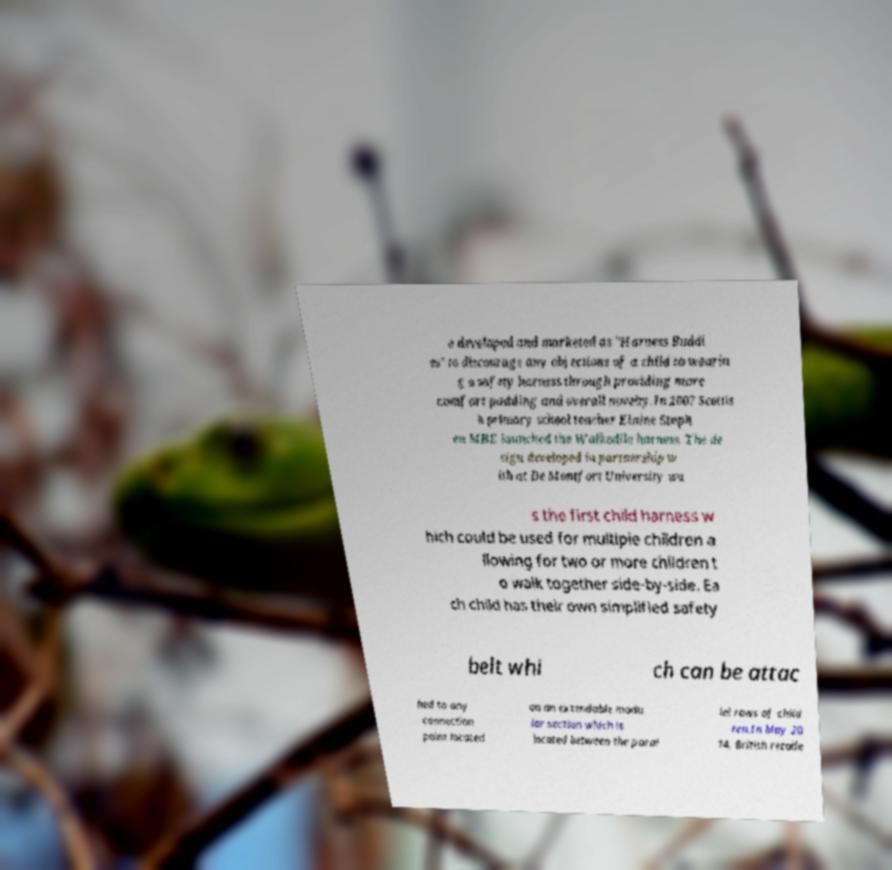I need the written content from this picture converted into text. Can you do that? e developed and marketed as "Harness Buddi es" to discourage any objections of a child to wearin g a safety harness through providing more comfort padding and overall novelty.In 2007 Scottis h primary school teacher Elaine Steph en MBE launched the Walkodile harness. The de sign developed in partnership w ith at De Montfort University wa s the first child harness w hich could be used for multiple children a llowing for two or more children t o walk together side-by-side. Ea ch child has their own simplified safety belt whi ch can be attac hed to any connection point located on an extendable modu lar section which is located between the paral lel rows of child ren.In May 20 14, British retaile 